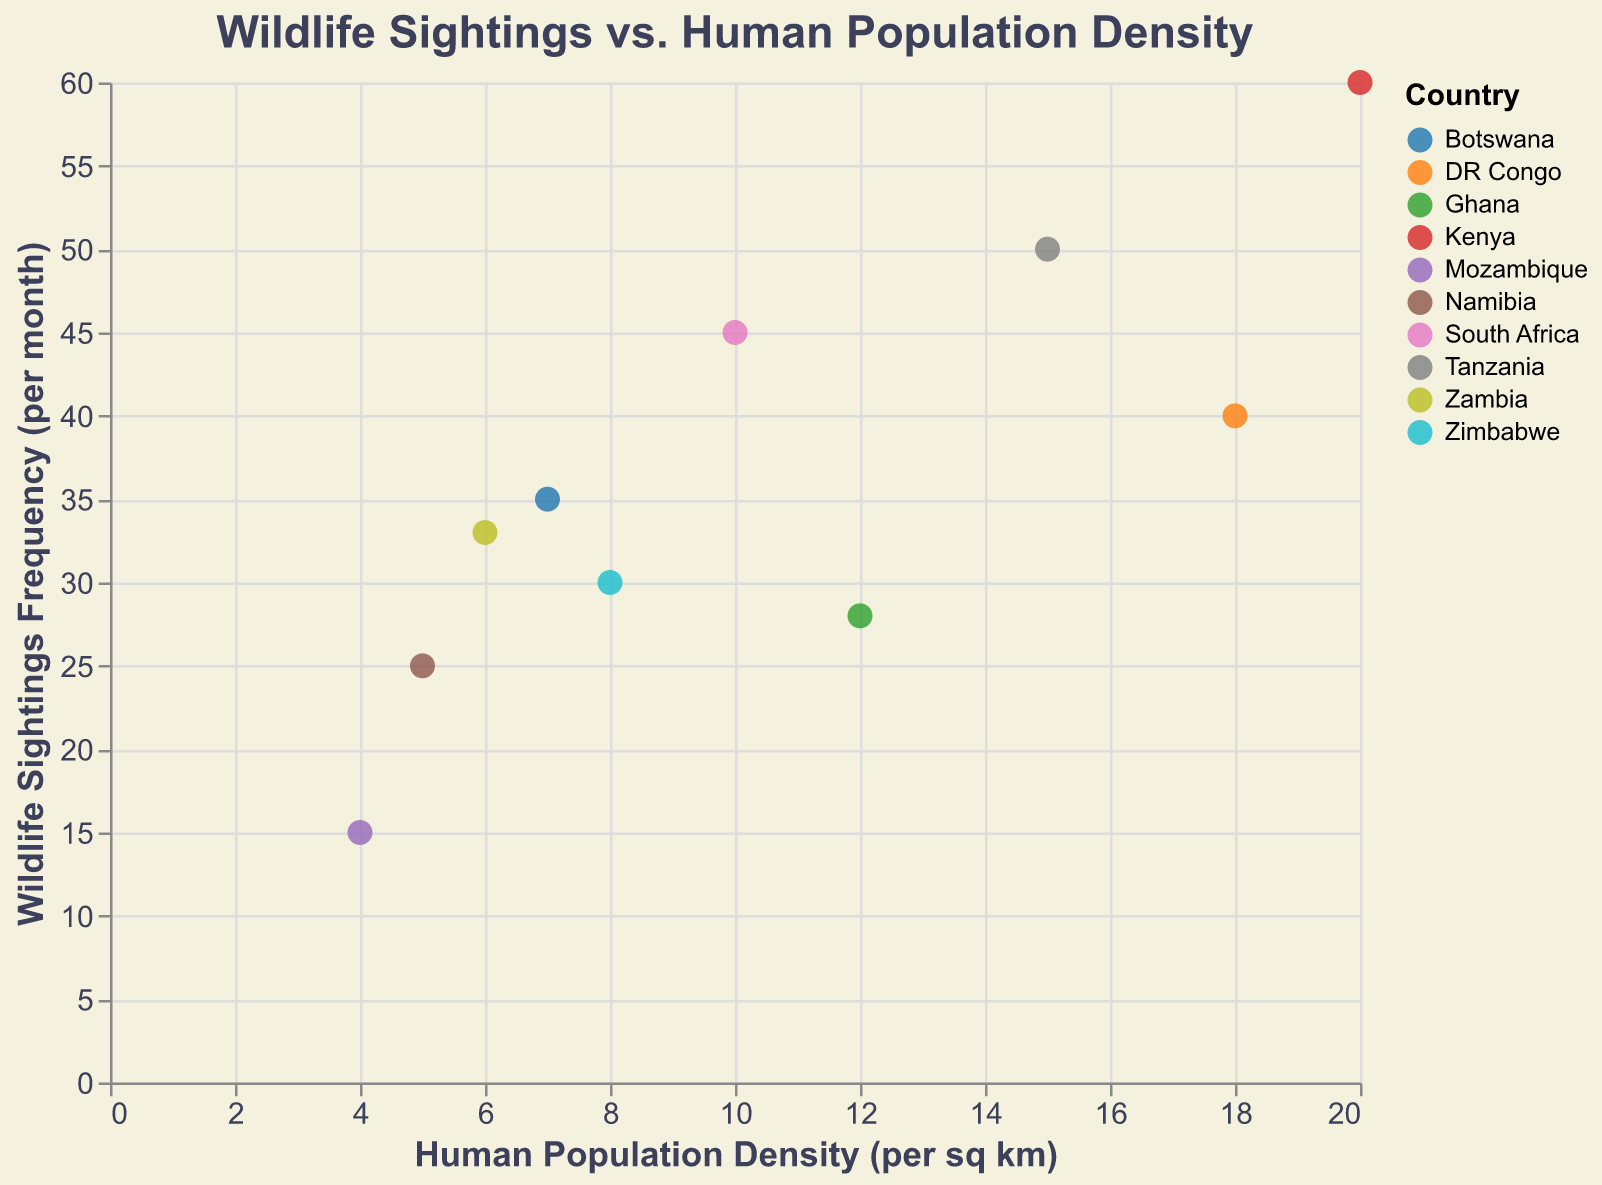How many protected areas are shown in the figure? Count the number of unique data points representing protected areas. Each data point corresponds to a protected area.
Answer: 10 What is the title of the figure? The title is usually at the top and describes the main content or purpose of the figure.
Answer: Wildlife Sightings vs. Human Population Density Which protected area has the highest wildlife sightings frequency? Look for the highest point on the y-axis and check its corresponding tooltip for the protected area name.
Answer: Masai Mara National Reserve What does the x-axis represent? The x-axis usually has a label indicating what it measures.
Answer: Human Population Density (per sq km) Which country has the most protected areas listed in the figure? Count the data points for each country and compare to see which has the most.
Answer: South Africa (with 1 entry among the provided data, although this is the specific count here, always check for context) What is the average human population density near the protected areas shown? Sum all the values of human population density and divide by the number of data points (10). The sum is 105 (10+15+20+5+8+7+4+18+6+12). The average is 105/10 = 10.5
Answer: 10.5 Compare the wildlife sightings frequency between Kruger National Park and Serengeti National Park. Which one is higher and by how much? Find the y-values for both parks: Kruger National Park (45), Serengeti National Park (50). Subtract the lower frequency from the higher frequency. 50 - 45 = 5
Answer: Serengeti National Park by 5 Is there a general trend between human population density and wildlife sightings frequency? Observe the overall pattern of data points in the plot. Analyze if higher human population densities generally correlate with higher or lower wildlife sightings frequencies.
Answer: Positive trend Which protected area has the lowest human population density, and what is the corresponding wildlife sightings frequency? Look for the lowest point on the x-axis and check its corresponding tooltip for human population density and wildlife sightings frequency.
Answer: Gorongosa National Park with 15 sightings per month 